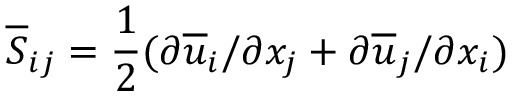<formula> <loc_0><loc_0><loc_500><loc_500>\overline { S } _ { i j } = \frac { 1 } { 2 } ( \partial \overline { u } _ { i } / \partial x _ { j } + \partial \overline { u } _ { j } / \partial x _ { i } )</formula> 